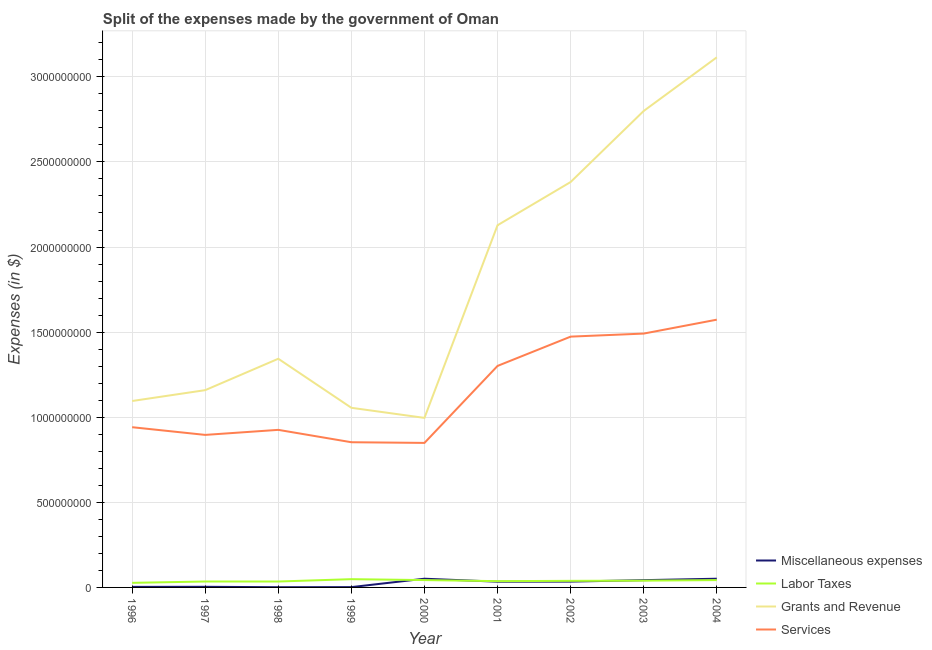Is the number of lines equal to the number of legend labels?
Make the answer very short. Yes. What is the amount spent on services in 2002?
Ensure brevity in your answer.  1.47e+09. Across all years, what is the maximum amount spent on services?
Your response must be concise. 1.57e+09. Across all years, what is the minimum amount spent on grants and revenue?
Your answer should be compact. 9.96e+08. What is the total amount spent on labor taxes in the graph?
Offer a very short reply. 3.46e+08. What is the difference between the amount spent on labor taxes in 2001 and that in 2003?
Keep it short and to the point. -3.00e+06. What is the difference between the amount spent on labor taxes in 2002 and the amount spent on grants and revenue in 2000?
Give a very brief answer. -9.58e+08. What is the average amount spent on services per year?
Provide a succinct answer. 1.15e+09. In the year 2000, what is the difference between the amount spent on services and amount spent on miscellaneous expenses?
Provide a succinct answer. 7.98e+08. What is the ratio of the amount spent on services in 1999 to that in 2000?
Ensure brevity in your answer.  1. Is the difference between the amount spent on miscellaneous expenses in 1998 and 2004 greater than the difference between the amount spent on grants and revenue in 1998 and 2004?
Keep it short and to the point. Yes. What is the difference between the highest and the second highest amount spent on grants and revenue?
Ensure brevity in your answer.  3.15e+08. What is the difference between the highest and the lowest amount spent on services?
Provide a short and direct response. 7.24e+08. In how many years, is the amount spent on labor taxes greater than the average amount spent on labor taxes taken over all years?
Ensure brevity in your answer.  5. Is the sum of the amount spent on services in 1996 and 2004 greater than the maximum amount spent on miscellaneous expenses across all years?
Your response must be concise. Yes. Is it the case that in every year, the sum of the amount spent on services and amount spent on miscellaneous expenses is greater than the sum of amount spent on labor taxes and amount spent on grants and revenue?
Your answer should be compact. No. Does the amount spent on labor taxes monotonically increase over the years?
Make the answer very short. No. Is the amount spent on miscellaneous expenses strictly greater than the amount spent on grants and revenue over the years?
Offer a terse response. No. Is the amount spent on services strictly less than the amount spent on miscellaneous expenses over the years?
Your response must be concise. No. What is the difference between two consecutive major ticks on the Y-axis?
Provide a short and direct response. 5.00e+08. Are the values on the major ticks of Y-axis written in scientific E-notation?
Give a very brief answer. No. Does the graph contain grids?
Offer a terse response. Yes. How many legend labels are there?
Your answer should be very brief. 4. How are the legend labels stacked?
Provide a succinct answer. Vertical. What is the title of the graph?
Give a very brief answer. Split of the expenses made by the government of Oman. What is the label or title of the X-axis?
Keep it short and to the point. Year. What is the label or title of the Y-axis?
Ensure brevity in your answer.  Expenses (in $). What is the Expenses (in $) in Miscellaneous expenses in 1996?
Make the answer very short. 3.20e+06. What is the Expenses (in $) in Labor Taxes in 1996?
Give a very brief answer. 2.69e+07. What is the Expenses (in $) of Grants and Revenue in 1996?
Offer a very short reply. 1.10e+09. What is the Expenses (in $) in Services in 1996?
Ensure brevity in your answer.  9.41e+08. What is the Expenses (in $) in Miscellaneous expenses in 1997?
Give a very brief answer. 3.70e+06. What is the Expenses (in $) of Labor Taxes in 1997?
Ensure brevity in your answer.  3.48e+07. What is the Expenses (in $) in Grants and Revenue in 1997?
Your answer should be very brief. 1.16e+09. What is the Expenses (in $) of Services in 1997?
Offer a terse response. 8.96e+08. What is the Expenses (in $) in Miscellaneous expenses in 1998?
Your answer should be very brief. 1.30e+06. What is the Expenses (in $) of Labor Taxes in 1998?
Provide a succinct answer. 3.47e+07. What is the Expenses (in $) in Grants and Revenue in 1998?
Make the answer very short. 1.34e+09. What is the Expenses (in $) of Services in 1998?
Your answer should be compact. 9.26e+08. What is the Expenses (in $) of Miscellaneous expenses in 1999?
Provide a succinct answer. 1.80e+06. What is the Expenses (in $) of Labor Taxes in 1999?
Offer a very short reply. 4.85e+07. What is the Expenses (in $) of Grants and Revenue in 1999?
Your answer should be compact. 1.06e+09. What is the Expenses (in $) of Services in 1999?
Your answer should be very brief. 8.53e+08. What is the Expenses (in $) of Miscellaneous expenses in 2000?
Your answer should be compact. 5.12e+07. What is the Expenses (in $) in Labor Taxes in 2000?
Keep it short and to the point. 4.32e+07. What is the Expenses (in $) of Grants and Revenue in 2000?
Make the answer very short. 9.96e+08. What is the Expenses (in $) of Services in 2000?
Make the answer very short. 8.49e+08. What is the Expenses (in $) of Miscellaneous expenses in 2001?
Give a very brief answer. 3.37e+07. What is the Expenses (in $) of Labor Taxes in 2001?
Provide a short and direct response. 3.68e+07. What is the Expenses (in $) of Grants and Revenue in 2001?
Ensure brevity in your answer.  2.13e+09. What is the Expenses (in $) in Services in 2001?
Provide a succinct answer. 1.30e+09. What is the Expenses (in $) of Miscellaneous expenses in 2002?
Keep it short and to the point. 3.43e+07. What is the Expenses (in $) of Labor Taxes in 2002?
Your answer should be compact. 3.87e+07. What is the Expenses (in $) of Grants and Revenue in 2002?
Your response must be concise. 2.38e+09. What is the Expenses (in $) of Services in 2002?
Keep it short and to the point. 1.47e+09. What is the Expenses (in $) of Miscellaneous expenses in 2003?
Your response must be concise. 4.27e+07. What is the Expenses (in $) of Labor Taxes in 2003?
Provide a short and direct response. 3.98e+07. What is the Expenses (in $) in Grants and Revenue in 2003?
Your answer should be compact. 2.80e+09. What is the Expenses (in $) of Services in 2003?
Make the answer very short. 1.49e+09. What is the Expenses (in $) of Miscellaneous expenses in 2004?
Offer a terse response. 5.12e+07. What is the Expenses (in $) in Labor Taxes in 2004?
Your answer should be very brief. 4.31e+07. What is the Expenses (in $) of Grants and Revenue in 2004?
Keep it short and to the point. 3.11e+09. What is the Expenses (in $) of Services in 2004?
Offer a very short reply. 1.57e+09. Across all years, what is the maximum Expenses (in $) of Miscellaneous expenses?
Offer a very short reply. 5.12e+07. Across all years, what is the maximum Expenses (in $) in Labor Taxes?
Offer a very short reply. 4.85e+07. Across all years, what is the maximum Expenses (in $) of Grants and Revenue?
Keep it short and to the point. 3.11e+09. Across all years, what is the maximum Expenses (in $) in Services?
Make the answer very short. 1.57e+09. Across all years, what is the minimum Expenses (in $) in Miscellaneous expenses?
Offer a very short reply. 1.30e+06. Across all years, what is the minimum Expenses (in $) in Labor Taxes?
Give a very brief answer. 2.69e+07. Across all years, what is the minimum Expenses (in $) of Grants and Revenue?
Your answer should be compact. 9.96e+08. Across all years, what is the minimum Expenses (in $) in Services?
Give a very brief answer. 8.49e+08. What is the total Expenses (in $) in Miscellaneous expenses in the graph?
Offer a very short reply. 2.23e+08. What is the total Expenses (in $) in Labor Taxes in the graph?
Make the answer very short. 3.46e+08. What is the total Expenses (in $) in Grants and Revenue in the graph?
Keep it short and to the point. 1.61e+1. What is the total Expenses (in $) of Services in the graph?
Offer a very short reply. 1.03e+1. What is the difference between the Expenses (in $) of Miscellaneous expenses in 1996 and that in 1997?
Make the answer very short. -5.00e+05. What is the difference between the Expenses (in $) in Labor Taxes in 1996 and that in 1997?
Make the answer very short. -7.90e+06. What is the difference between the Expenses (in $) of Grants and Revenue in 1996 and that in 1997?
Make the answer very short. -6.38e+07. What is the difference between the Expenses (in $) of Services in 1996 and that in 1997?
Give a very brief answer. 4.52e+07. What is the difference between the Expenses (in $) in Miscellaneous expenses in 1996 and that in 1998?
Your answer should be compact. 1.90e+06. What is the difference between the Expenses (in $) of Labor Taxes in 1996 and that in 1998?
Make the answer very short. -7.80e+06. What is the difference between the Expenses (in $) of Grants and Revenue in 1996 and that in 1998?
Give a very brief answer. -2.48e+08. What is the difference between the Expenses (in $) of Services in 1996 and that in 1998?
Your response must be concise. 1.56e+07. What is the difference between the Expenses (in $) in Miscellaneous expenses in 1996 and that in 1999?
Give a very brief answer. 1.40e+06. What is the difference between the Expenses (in $) of Labor Taxes in 1996 and that in 1999?
Provide a succinct answer. -2.16e+07. What is the difference between the Expenses (in $) of Grants and Revenue in 1996 and that in 1999?
Provide a short and direct response. 3.99e+07. What is the difference between the Expenses (in $) of Services in 1996 and that in 1999?
Make the answer very short. 8.83e+07. What is the difference between the Expenses (in $) of Miscellaneous expenses in 1996 and that in 2000?
Keep it short and to the point. -4.80e+07. What is the difference between the Expenses (in $) of Labor Taxes in 1996 and that in 2000?
Give a very brief answer. -1.63e+07. What is the difference between the Expenses (in $) of Grants and Revenue in 1996 and that in 2000?
Provide a short and direct response. 9.91e+07. What is the difference between the Expenses (in $) in Services in 1996 and that in 2000?
Ensure brevity in your answer.  9.23e+07. What is the difference between the Expenses (in $) of Miscellaneous expenses in 1996 and that in 2001?
Offer a very short reply. -3.05e+07. What is the difference between the Expenses (in $) of Labor Taxes in 1996 and that in 2001?
Your response must be concise. -9.90e+06. What is the difference between the Expenses (in $) in Grants and Revenue in 1996 and that in 2001?
Your response must be concise. -1.03e+09. What is the difference between the Expenses (in $) of Services in 1996 and that in 2001?
Provide a succinct answer. -3.60e+08. What is the difference between the Expenses (in $) in Miscellaneous expenses in 1996 and that in 2002?
Offer a very short reply. -3.11e+07. What is the difference between the Expenses (in $) of Labor Taxes in 1996 and that in 2002?
Your answer should be compact. -1.18e+07. What is the difference between the Expenses (in $) of Grants and Revenue in 1996 and that in 2002?
Your response must be concise. -1.29e+09. What is the difference between the Expenses (in $) of Services in 1996 and that in 2002?
Your response must be concise. -5.32e+08. What is the difference between the Expenses (in $) of Miscellaneous expenses in 1996 and that in 2003?
Your answer should be compact. -3.95e+07. What is the difference between the Expenses (in $) in Labor Taxes in 1996 and that in 2003?
Make the answer very short. -1.29e+07. What is the difference between the Expenses (in $) in Grants and Revenue in 1996 and that in 2003?
Provide a short and direct response. -1.70e+09. What is the difference between the Expenses (in $) of Services in 1996 and that in 2003?
Provide a succinct answer. -5.50e+08. What is the difference between the Expenses (in $) in Miscellaneous expenses in 1996 and that in 2004?
Your answer should be very brief. -4.80e+07. What is the difference between the Expenses (in $) in Labor Taxes in 1996 and that in 2004?
Keep it short and to the point. -1.62e+07. What is the difference between the Expenses (in $) of Grants and Revenue in 1996 and that in 2004?
Your answer should be very brief. -2.02e+09. What is the difference between the Expenses (in $) of Services in 1996 and that in 2004?
Provide a short and direct response. -6.32e+08. What is the difference between the Expenses (in $) of Miscellaneous expenses in 1997 and that in 1998?
Ensure brevity in your answer.  2.40e+06. What is the difference between the Expenses (in $) in Labor Taxes in 1997 and that in 1998?
Your answer should be very brief. 1.00e+05. What is the difference between the Expenses (in $) of Grants and Revenue in 1997 and that in 1998?
Offer a terse response. -1.84e+08. What is the difference between the Expenses (in $) of Services in 1997 and that in 1998?
Your response must be concise. -2.96e+07. What is the difference between the Expenses (in $) of Miscellaneous expenses in 1997 and that in 1999?
Your answer should be compact. 1.90e+06. What is the difference between the Expenses (in $) in Labor Taxes in 1997 and that in 1999?
Make the answer very short. -1.37e+07. What is the difference between the Expenses (in $) of Grants and Revenue in 1997 and that in 1999?
Ensure brevity in your answer.  1.04e+08. What is the difference between the Expenses (in $) of Services in 1997 and that in 1999?
Your answer should be very brief. 4.31e+07. What is the difference between the Expenses (in $) of Miscellaneous expenses in 1997 and that in 2000?
Keep it short and to the point. -4.75e+07. What is the difference between the Expenses (in $) in Labor Taxes in 1997 and that in 2000?
Ensure brevity in your answer.  -8.40e+06. What is the difference between the Expenses (in $) of Grants and Revenue in 1997 and that in 2000?
Ensure brevity in your answer.  1.63e+08. What is the difference between the Expenses (in $) in Services in 1997 and that in 2000?
Provide a short and direct response. 4.71e+07. What is the difference between the Expenses (in $) in Miscellaneous expenses in 1997 and that in 2001?
Your answer should be compact. -3.00e+07. What is the difference between the Expenses (in $) in Labor Taxes in 1997 and that in 2001?
Ensure brevity in your answer.  -2.00e+06. What is the difference between the Expenses (in $) in Grants and Revenue in 1997 and that in 2001?
Make the answer very short. -9.69e+08. What is the difference between the Expenses (in $) in Services in 1997 and that in 2001?
Your answer should be compact. -4.05e+08. What is the difference between the Expenses (in $) in Miscellaneous expenses in 1997 and that in 2002?
Your response must be concise. -3.06e+07. What is the difference between the Expenses (in $) of Labor Taxes in 1997 and that in 2002?
Your response must be concise. -3.90e+06. What is the difference between the Expenses (in $) of Grants and Revenue in 1997 and that in 2002?
Provide a succinct answer. -1.22e+09. What is the difference between the Expenses (in $) in Services in 1997 and that in 2002?
Your response must be concise. -5.77e+08. What is the difference between the Expenses (in $) of Miscellaneous expenses in 1997 and that in 2003?
Give a very brief answer. -3.90e+07. What is the difference between the Expenses (in $) in Labor Taxes in 1997 and that in 2003?
Ensure brevity in your answer.  -5.00e+06. What is the difference between the Expenses (in $) of Grants and Revenue in 1997 and that in 2003?
Keep it short and to the point. -1.64e+09. What is the difference between the Expenses (in $) of Services in 1997 and that in 2003?
Your answer should be compact. -5.95e+08. What is the difference between the Expenses (in $) of Miscellaneous expenses in 1997 and that in 2004?
Provide a short and direct response. -4.75e+07. What is the difference between the Expenses (in $) of Labor Taxes in 1997 and that in 2004?
Give a very brief answer. -8.30e+06. What is the difference between the Expenses (in $) in Grants and Revenue in 1997 and that in 2004?
Give a very brief answer. -1.96e+09. What is the difference between the Expenses (in $) in Services in 1997 and that in 2004?
Offer a terse response. -6.77e+08. What is the difference between the Expenses (in $) of Miscellaneous expenses in 1998 and that in 1999?
Give a very brief answer. -5.00e+05. What is the difference between the Expenses (in $) in Labor Taxes in 1998 and that in 1999?
Offer a very short reply. -1.38e+07. What is the difference between the Expenses (in $) of Grants and Revenue in 1998 and that in 1999?
Provide a short and direct response. 2.88e+08. What is the difference between the Expenses (in $) in Services in 1998 and that in 1999?
Keep it short and to the point. 7.27e+07. What is the difference between the Expenses (in $) of Miscellaneous expenses in 1998 and that in 2000?
Give a very brief answer. -4.99e+07. What is the difference between the Expenses (in $) of Labor Taxes in 1998 and that in 2000?
Provide a succinct answer. -8.50e+06. What is the difference between the Expenses (in $) of Grants and Revenue in 1998 and that in 2000?
Your answer should be very brief. 3.47e+08. What is the difference between the Expenses (in $) in Services in 1998 and that in 2000?
Give a very brief answer. 7.67e+07. What is the difference between the Expenses (in $) of Miscellaneous expenses in 1998 and that in 2001?
Provide a succinct answer. -3.24e+07. What is the difference between the Expenses (in $) in Labor Taxes in 1998 and that in 2001?
Your answer should be very brief. -2.10e+06. What is the difference between the Expenses (in $) in Grants and Revenue in 1998 and that in 2001?
Your response must be concise. -7.84e+08. What is the difference between the Expenses (in $) of Services in 1998 and that in 2001?
Provide a succinct answer. -3.76e+08. What is the difference between the Expenses (in $) in Miscellaneous expenses in 1998 and that in 2002?
Offer a terse response. -3.30e+07. What is the difference between the Expenses (in $) of Labor Taxes in 1998 and that in 2002?
Your answer should be compact. -4.00e+06. What is the difference between the Expenses (in $) in Grants and Revenue in 1998 and that in 2002?
Ensure brevity in your answer.  -1.04e+09. What is the difference between the Expenses (in $) of Services in 1998 and that in 2002?
Your answer should be compact. -5.48e+08. What is the difference between the Expenses (in $) in Miscellaneous expenses in 1998 and that in 2003?
Your answer should be compact. -4.14e+07. What is the difference between the Expenses (in $) of Labor Taxes in 1998 and that in 2003?
Your answer should be compact. -5.10e+06. What is the difference between the Expenses (in $) in Grants and Revenue in 1998 and that in 2003?
Provide a succinct answer. -1.46e+09. What is the difference between the Expenses (in $) in Services in 1998 and that in 2003?
Provide a short and direct response. -5.66e+08. What is the difference between the Expenses (in $) of Miscellaneous expenses in 1998 and that in 2004?
Provide a succinct answer. -4.99e+07. What is the difference between the Expenses (in $) of Labor Taxes in 1998 and that in 2004?
Provide a succinct answer. -8.40e+06. What is the difference between the Expenses (in $) in Grants and Revenue in 1998 and that in 2004?
Offer a terse response. -1.77e+09. What is the difference between the Expenses (in $) of Services in 1998 and that in 2004?
Make the answer very short. -6.47e+08. What is the difference between the Expenses (in $) in Miscellaneous expenses in 1999 and that in 2000?
Your answer should be very brief. -4.94e+07. What is the difference between the Expenses (in $) of Labor Taxes in 1999 and that in 2000?
Your answer should be very brief. 5.30e+06. What is the difference between the Expenses (in $) in Grants and Revenue in 1999 and that in 2000?
Give a very brief answer. 5.92e+07. What is the difference between the Expenses (in $) in Miscellaneous expenses in 1999 and that in 2001?
Give a very brief answer. -3.19e+07. What is the difference between the Expenses (in $) in Labor Taxes in 1999 and that in 2001?
Give a very brief answer. 1.17e+07. What is the difference between the Expenses (in $) of Grants and Revenue in 1999 and that in 2001?
Your answer should be compact. -1.07e+09. What is the difference between the Expenses (in $) in Services in 1999 and that in 2001?
Provide a short and direct response. -4.48e+08. What is the difference between the Expenses (in $) in Miscellaneous expenses in 1999 and that in 2002?
Offer a terse response. -3.25e+07. What is the difference between the Expenses (in $) in Labor Taxes in 1999 and that in 2002?
Make the answer very short. 9.80e+06. What is the difference between the Expenses (in $) of Grants and Revenue in 1999 and that in 2002?
Keep it short and to the point. -1.33e+09. What is the difference between the Expenses (in $) of Services in 1999 and that in 2002?
Your answer should be compact. -6.20e+08. What is the difference between the Expenses (in $) of Miscellaneous expenses in 1999 and that in 2003?
Provide a succinct answer. -4.09e+07. What is the difference between the Expenses (in $) of Labor Taxes in 1999 and that in 2003?
Ensure brevity in your answer.  8.70e+06. What is the difference between the Expenses (in $) in Grants and Revenue in 1999 and that in 2003?
Offer a terse response. -1.74e+09. What is the difference between the Expenses (in $) in Services in 1999 and that in 2003?
Provide a succinct answer. -6.38e+08. What is the difference between the Expenses (in $) in Miscellaneous expenses in 1999 and that in 2004?
Your answer should be very brief. -4.94e+07. What is the difference between the Expenses (in $) of Labor Taxes in 1999 and that in 2004?
Provide a succinct answer. 5.40e+06. What is the difference between the Expenses (in $) of Grants and Revenue in 1999 and that in 2004?
Provide a short and direct response. -2.06e+09. What is the difference between the Expenses (in $) in Services in 1999 and that in 2004?
Ensure brevity in your answer.  -7.20e+08. What is the difference between the Expenses (in $) of Miscellaneous expenses in 2000 and that in 2001?
Provide a short and direct response. 1.75e+07. What is the difference between the Expenses (in $) of Labor Taxes in 2000 and that in 2001?
Ensure brevity in your answer.  6.40e+06. What is the difference between the Expenses (in $) in Grants and Revenue in 2000 and that in 2001?
Offer a very short reply. -1.13e+09. What is the difference between the Expenses (in $) in Services in 2000 and that in 2001?
Your answer should be compact. -4.52e+08. What is the difference between the Expenses (in $) of Miscellaneous expenses in 2000 and that in 2002?
Provide a short and direct response. 1.69e+07. What is the difference between the Expenses (in $) in Labor Taxes in 2000 and that in 2002?
Provide a succinct answer. 4.50e+06. What is the difference between the Expenses (in $) of Grants and Revenue in 2000 and that in 2002?
Offer a terse response. -1.39e+09. What is the difference between the Expenses (in $) of Services in 2000 and that in 2002?
Provide a short and direct response. -6.24e+08. What is the difference between the Expenses (in $) of Miscellaneous expenses in 2000 and that in 2003?
Your answer should be compact. 8.50e+06. What is the difference between the Expenses (in $) in Labor Taxes in 2000 and that in 2003?
Keep it short and to the point. 3.40e+06. What is the difference between the Expenses (in $) in Grants and Revenue in 2000 and that in 2003?
Give a very brief answer. -1.80e+09. What is the difference between the Expenses (in $) in Services in 2000 and that in 2003?
Give a very brief answer. -6.42e+08. What is the difference between the Expenses (in $) in Miscellaneous expenses in 2000 and that in 2004?
Provide a succinct answer. 0. What is the difference between the Expenses (in $) of Labor Taxes in 2000 and that in 2004?
Ensure brevity in your answer.  1.00e+05. What is the difference between the Expenses (in $) in Grants and Revenue in 2000 and that in 2004?
Offer a terse response. -2.12e+09. What is the difference between the Expenses (in $) in Services in 2000 and that in 2004?
Offer a very short reply. -7.24e+08. What is the difference between the Expenses (in $) in Miscellaneous expenses in 2001 and that in 2002?
Give a very brief answer. -6.00e+05. What is the difference between the Expenses (in $) of Labor Taxes in 2001 and that in 2002?
Your response must be concise. -1.90e+06. What is the difference between the Expenses (in $) of Grants and Revenue in 2001 and that in 2002?
Your response must be concise. -2.54e+08. What is the difference between the Expenses (in $) in Services in 2001 and that in 2002?
Offer a terse response. -1.72e+08. What is the difference between the Expenses (in $) in Miscellaneous expenses in 2001 and that in 2003?
Make the answer very short. -9.00e+06. What is the difference between the Expenses (in $) of Grants and Revenue in 2001 and that in 2003?
Your response must be concise. -6.72e+08. What is the difference between the Expenses (in $) of Services in 2001 and that in 2003?
Provide a short and direct response. -1.90e+08. What is the difference between the Expenses (in $) of Miscellaneous expenses in 2001 and that in 2004?
Provide a succinct answer. -1.75e+07. What is the difference between the Expenses (in $) in Labor Taxes in 2001 and that in 2004?
Your answer should be compact. -6.30e+06. What is the difference between the Expenses (in $) in Grants and Revenue in 2001 and that in 2004?
Give a very brief answer. -9.87e+08. What is the difference between the Expenses (in $) of Services in 2001 and that in 2004?
Your answer should be very brief. -2.72e+08. What is the difference between the Expenses (in $) in Miscellaneous expenses in 2002 and that in 2003?
Keep it short and to the point. -8.40e+06. What is the difference between the Expenses (in $) in Labor Taxes in 2002 and that in 2003?
Provide a succinct answer. -1.10e+06. What is the difference between the Expenses (in $) of Grants and Revenue in 2002 and that in 2003?
Offer a very short reply. -4.18e+08. What is the difference between the Expenses (in $) in Services in 2002 and that in 2003?
Provide a succinct answer. -1.79e+07. What is the difference between the Expenses (in $) in Miscellaneous expenses in 2002 and that in 2004?
Your response must be concise. -1.69e+07. What is the difference between the Expenses (in $) in Labor Taxes in 2002 and that in 2004?
Make the answer very short. -4.40e+06. What is the difference between the Expenses (in $) of Grants and Revenue in 2002 and that in 2004?
Provide a short and direct response. -7.33e+08. What is the difference between the Expenses (in $) in Services in 2002 and that in 2004?
Provide a short and direct response. -9.96e+07. What is the difference between the Expenses (in $) of Miscellaneous expenses in 2003 and that in 2004?
Your response must be concise. -8.50e+06. What is the difference between the Expenses (in $) in Labor Taxes in 2003 and that in 2004?
Offer a terse response. -3.30e+06. What is the difference between the Expenses (in $) in Grants and Revenue in 2003 and that in 2004?
Your answer should be compact. -3.15e+08. What is the difference between the Expenses (in $) of Services in 2003 and that in 2004?
Ensure brevity in your answer.  -8.17e+07. What is the difference between the Expenses (in $) of Miscellaneous expenses in 1996 and the Expenses (in $) of Labor Taxes in 1997?
Make the answer very short. -3.16e+07. What is the difference between the Expenses (in $) in Miscellaneous expenses in 1996 and the Expenses (in $) in Grants and Revenue in 1997?
Give a very brief answer. -1.16e+09. What is the difference between the Expenses (in $) in Miscellaneous expenses in 1996 and the Expenses (in $) in Services in 1997?
Your answer should be very brief. -8.93e+08. What is the difference between the Expenses (in $) of Labor Taxes in 1996 and the Expenses (in $) of Grants and Revenue in 1997?
Your response must be concise. -1.13e+09. What is the difference between the Expenses (in $) of Labor Taxes in 1996 and the Expenses (in $) of Services in 1997?
Ensure brevity in your answer.  -8.69e+08. What is the difference between the Expenses (in $) in Grants and Revenue in 1996 and the Expenses (in $) in Services in 1997?
Keep it short and to the point. 1.99e+08. What is the difference between the Expenses (in $) of Miscellaneous expenses in 1996 and the Expenses (in $) of Labor Taxes in 1998?
Ensure brevity in your answer.  -3.15e+07. What is the difference between the Expenses (in $) of Miscellaneous expenses in 1996 and the Expenses (in $) of Grants and Revenue in 1998?
Provide a short and direct response. -1.34e+09. What is the difference between the Expenses (in $) of Miscellaneous expenses in 1996 and the Expenses (in $) of Services in 1998?
Your response must be concise. -9.23e+08. What is the difference between the Expenses (in $) of Labor Taxes in 1996 and the Expenses (in $) of Grants and Revenue in 1998?
Provide a short and direct response. -1.32e+09. What is the difference between the Expenses (in $) of Labor Taxes in 1996 and the Expenses (in $) of Services in 1998?
Provide a succinct answer. -8.99e+08. What is the difference between the Expenses (in $) in Grants and Revenue in 1996 and the Expenses (in $) in Services in 1998?
Provide a succinct answer. 1.70e+08. What is the difference between the Expenses (in $) in Miscellaneous expenses in 1996 and the Expenses (in $) in Labor Taxes in 1999?
Offer a very short reply. -4.53e+07. What is the difference between the Expenses (in $) of Miscellaneous expenses in 1996 and the Expenses (in $) of Grants and Revenue in 1999?
Offer a terse response. -1.05e+09. What is the difference between the Expenses (in $) of Miscellaneous expenses in 1996 and the Expenses (in $) of Services in 1999?
Keep it short and to the point. -8.50e+08. What is the difference between the Expenses (in $) of Labor Taxes in 1996 and the Expenses (in $) of Grants and Revenue in 1999?
Your answer should be very brief. -1.03e+09. What is the difference between the Expenses (in $) of Labor Taxes in 1996 and the Expenses (in $) of Services in 1999?
Your answer should be compact. -8.26e+08. What is the difference between the Expenses (in $) of Grants and Revenue in 1996 and the Expenses (in $) of Services in 1999?
Offer a terse response. 2.42e+08. What is the difference between the Expenses (in $) of Miscellaneous expenses in 1996 and the Expenses (in $) of Labor Taxes in 2000?
Ensure brevity in your answer.  -4.00e+07. What is the difference between the Expenses (in $) of Miscellaneous expenses in 1996 and the Expenses (in $) of Grants and Revenue in 2000?
Offer a terse response. -9.93e+08. What is the difference between the Expenses (in $) of Miscellaneous expenses in 1996 and the Expenses (in $) of Services in 2000?
Ensure brevity in your answer.  -8.46e+08. What is the difference between the Expenses (in $) in Labor Taxes in 1996 and the Expenses (in $) in Grants and Revenue in 2000?
Make the answer very short. -9.69e+08. What is the difference between the Expenses (in $) in Labor Taxes in 1996 and the Expenses (in $) in Services in 2000?
Offer a very short reply. -8.22e+08. What is the difference between the Expenses (in $) in Grants and Revenue in 1996 and the Expenses (in $) in Services in 2000?
Provide a succinct answer. 2.46e+08. What is the difference between the Expenses (in $) of Miscellaneous expenses in 1996 and the Expenses (in $) of Labor Taxes in 2001?
Your answer should be very brief. -3.36e+07. What is the difference between the Expenses (in $) in Miscellaneous expenses in 1996 and the Expenses (in $) in Grants and Revenue in 2001?
Provide a succinct answer. -2.12e+09. What is the difference between the Expenses (in $) in Miscellaneous expenses in 1996 and the Expenses (in $) in Services in 2001?
Provide a succinct answer. -1.30e+09. What is the difference between the Expenses (in $) in Labor Taxes in 1996 and the Expenses (in $) in Grants and Revenue in 2001?
Ensure brevity in your answer.  -2.10e+09. What is the difference between the Expenses (in $) of Labor Taxes in 1996 and the Expenses (in $) of Services in 2001?
Your answer should be compact. -1.27e+09. What is the difference between the Expenses (in $) of Grants and Revenue in 1996 and the Expenses (in $) of Services in 2001?
Offer a terse response. -2.06e+08. What is the difference between the Expenses (in $) in Miscellaneous expenses in 1996 and the Expenses (in $) in Labor Taxes in 2002?
Your answer should be compact. -3.55e+07. What is the difference between the Expenses (in $) in Miscellaneous expenses in 1996 and the Expenses (in $) in Grants and Revenue in 2002?
Provide a short and direct response. -2.38e+09. What is the difference between the Expenses (in $) in Miscellaneous expenses in 1996 and the Expenses (in $) in Services in 2002?
Provide a succinct answer. -1.47e+09. What is the difference between the Expenses (in $) of Labor Taxes in 1996 and the Expenses (in $) of Grants and Revenue in 2002?
Offer a terse response. -2.36e+09. What is the difference between the Expenses (in $) in Labor Taxes in 1996 and the Expenses (in $) in Services in 2002?
Keep it short and to the point. -1.45e+09. What is the difference between the Expenses (in $) in Grants and Revenue in 1996 and the Expenses (in $) in Services in 2002?
Your answer should be very brief. -3.78e+08. What is the difference between the Expenses (in $) of Miscellaneous expenses in 1996 and the Expenses (in $) of Labor Taxes in 2003?
Keep it short and to the point. -3.66e+07. What is the difference between the Expenses (in $) of Miscellaneous expenses in 1996 and the Expenses (in $) of Grants and Revenue in 2003?
Your response must be concise. -2.80e+09. What is the difference between the Expenses (in $) in Miscellaneous expenses in 1996 and the Expenses (in $) in Services in 2003?
Offer a terse response. -1.49e+09. What is the difference between the Expenses (in $) in Labor Taxes in 1996 and the Expenses (in $) in Grants and Revenue in 2003?
Offer a terse response. -2.77e+09. What is the difference between the Expenses (in $) of Labor Taxes in 1996 and the Expenses (in $) of Services in 2003?
Your answer should be very brief. -1.46e+09. What is the difference between the Expenses (in $) of Grants and Revenue in 1996 and the Expenses (in $) of Services in 2003?
Your answer should be compact. -3.96e+08. What is the difference between the Expenses (in $) in Miscellaneous expenses in 1996 and the Expenses (in $) in Labor Taxes in 2004?
Your response must be concise. -3.99e+07. What is the difference between the Expenses (in $) of Miscellaneous expenses in 1996 and the Expenses (in $) of Grants and Revenue in 2004?
Ensure brevity in your answer.  -3.11e+09. What is the difference between the Expenses (in $) of Miscellaneous expenses in 1996 and the Expenses (in $) of Services in 2004?
Offer a terse response. -1.57e+09. What is the difference between the Expenses (in $) of Labor Taxes in 1996 and the Expenses (in $) of Grants and Revenue in 2004?
Offer a terse response. -3.09e+09. What is the difference between the Expenses (in $) in Labor Taxes in 1996 and the Expenses (in $) in Services in 2004?
Provide a succinct answer. -1.55e+09. What is the difference between the Expenses (in $) in Grants and Revenue in 1996 and the Expenses (in $) in Services in 2004?
Make the answer very short. -4.78e+08. What is the difference between the Expenses (in $) of Miscellaneous expenses in 1997 and the Expenses (in $) of Labor Taxes in 1998?
Keep it short and to the point. -3.10e+07. What is the difference between the Expenses (in $) of Miscellaneous expenses in 1997 and the Expenses (in $) of Grants and Revenue in 1998?
Your answer should be very brief. -1.34e+09. What is the difference between the Expenses (in $) in Miscellaneous expenses in 1997 and the Expenses (in $) in Services in 1998?
Provide a short and direct response. -9.22e+08. What is the difference between the Expenses (in $) of Labor Taxes in 1997 and the Expenses (in $) of Grants and Revenue in 1998?
Offer a terse response. -1.31e+09. What is the difference between the Expenses (in $) in Labor Taxes in 1997 and the Expenses (in $) in Services in 1998?
Offer a very short reply. -8.91e+08. What is the difference between the Expenses (in $) in Grants and Revenue in 1997 and the Expenses (in $) in Services in 1998?
Provide a succinct answer. 2.33e+08. What is the difference between the Expenses (in $) of Miscellaneous expenses in 1997 and the Expenses (in $) of Labor Taxes in 1999?
Offer a terse response. -4.48e+07. What is the difference between the Expenses (in $) in Miscellaneous expenses in 1997 and the Expenses (in $) in Grants and Revenue in 1999?
Provide a short and direct response. -1.05e+09. What is the difference between the Expenses (in $) of Miscellaneous expenses in 1997 and the Expenses (in $) of Services in 1999?
Give a very brief answer. -8.49e+08. What is the difference between the Expenses (in $) of Labor Taxes in 1997 and the Expenses (in $) of Grants and Revenue in 1999?
Provide a succinct answer. -1.02e+09. What is the difference between the Expenses (in $) of Labor Taxes in 1997 and the Expenses (in $) of Services in 1999?
Ensure brevity in your answer.  -8.18e+08. What is the difference between the Expenses (in $) in Grants and Revenue in 1997 and the Expenses (in $) in Services in 1999?
Your answer should be very brief. 3.06e+08. What is the difference between the Expenses (in $) in Miscellaneous expenses in 1997 and the Expenses (in $) in Labor Taxes in 2000?
Your response must be concise. -3.95e+07. What is the difference between the Expenses (in $) of Miscellaneous expenses in 1997 and the Expenses (in $) of Grants and Revenue in 2000?
Keep it short and to the point. -9.92e+08. What is the difference between the Expenses (in $) of Miscellaneous expenses in 1997 and the Expenses (in $) of Services in 2000?
Your answer should be compact. -8.45e+08. What is the difference between the Expenses (in $) of Labor Taxes in 1997 and the Expenses (in $) of Grants and Revenue in 2000?
Ensure brevity in your answer.  -9.61e+08. What is the difference between the Expenses (in $) in Labor Taxes in 1997 and the Expenses (in $) in Services in 2000?
Your answer should be very brief. -8.14e+08. What is the difference between the Expenses (in $) in Grants and Revenue in 1997 and the Expenses (in $) in Services in 2000?
Offer a very short reply. 3.10e+08. What is the difference between the Expenses (in $) in Miscellaneous expenses in 1997 and the Expenses (in $) in Labor Taxes in 2001?
Offer a terse response. -3.31e+07. What is the difference between the Expenses (in $) in Miscellaneous expenses in 1997 and the Expenses (in $) in Grants and Revenue in 2001?
Give a very brief answer. -2.12e+09. What is the difference between the Expenses (in $) of Miscellaneous expenses in 1997 and the Expenses (in $) of Services in 2001?
Offer a very short reply. -1.30e+09. What is the difference between the Expenses (in $) of Labor Taxes in 1997 and the Expenses (in $) of Grants and Revenue in 2001?
Make the answer very short. -2.09e+09. What is the difference between the Expenses (in $) of Labor Taxes in 1997 and the Expenses (in $) of Services in 2001?
Offer a terse response. -1.27e+09. What is the difference between the Expenses (in $) of Grants and Revenue in 1997 and the Expenses (in $) of Services in 2001?
Provide a succinct answer. -1.42e+08. What is the difference between the Expenses (in $) of Miscellaneous expenses in 1997 and the Expenses (in $) of Labor Taxes in 2002?
Your answer should be very brief. -3.50e+07. What is the difference between the Expenses (in $) of Miscellaneous expenses in 1997 and the Expenses (in $) of Grants and Revenue in 2002?
Offer a very short reply. -2.38e+09. What is the difference between the Expenses (in $) in Miscellaneous expenses in 1997 and the Expenses (in $) in Services in 2002?
Give a very brief answer. -1.47e+09. What is the difference between the Expenses (in $) in Labor Taxes in 1997 and the Expenses (in $) in Grants and Revenue in 2002?
Give a very brief answer. -2.35e+09. What is the difference between the Expenses (in $) in Labor Taxes in 1997 and the Expenses (in $) in Services in 2002?
Make the answer very short. -1.44e+09. What is the difference between the Expenses (in $) of Grants and Revenue in 1997 and the Expenses (in $) of Services in 2002?
Provide a short and direct response. -3.14e+08. What is the difference between the Expenses (in $) of Miscellaneous expenses in 1997 and the Expenses (in $) of Labor Taxes in 2003?
Offer a very short reply. -3.61e+07. What is the difference between the Expenses (in $) in Miscellaneous expenses in 1997 and the Expenses (in $) in Grants and Revenue in 2003?
Ensure brevity in your answer.  -2.80e+09. What is the difference between the Expenses (in $) in Miscellaneous expenses in 1997 and the Expenses (in $) in Services in 2003?
Give a very brief answer. -1.49e+09. What is the difference between the Expenses (in $) in Labor Taxes in 1997 and the Expenses (in $) in Grants and Revenue in 2003?
Provide a short and direct response. -2.76e+09. What is the difference between the Expenses (in $) in Labor Taxes in 1997 and the Expenses (in $) in Services in 2003?
Your answer should be compact. -1.46e+09. What is the difference between the Expenses (in $) in Grants and Revenue in 1997 and the Expenses (in $) in Services in 2003?
Ensure brevity in your answer.  -3.32e+08. What is the difference between the Expenses (in $) of Miscellaneous expenses in 1997 and the Expenses (in $) of Labor Taxes in 2004?
Offer a terse response. -3.94e+07. What is the difference between the Expenses (in $) of Miscellaneous expenses in 1997 and the Expenses (in $) of Grants and Revenue in 2004?
Make the answer very short. -3.11e+09. What is the difference between the Expenses (in $) of Miscellaneous expenses in 1997 and the Expenses (in $) of Services in 2004?
Provide a short and direct response. -1.57e+09. What is the difference between the Expenses (in $) of Labor Taxes in 1997 and the Expenses (in $) of Grants and Revenue in 2004?
Offer a terse response. -3.08e+09. What is the difference between the Expenses (in $) in Labor Taxes in 1997 and the Expenses (in $) in Services in 2004?
Your answer should be very brief. -1.54e+09. What is the difference between the Expenses (in $) of Grants and Revenue in 1997 and the Expenses (in $) of Services in 2004?
Keep it short and to the point. -4.14e+08. What is the difference between the Expenses (in $) of Miscellaneous expenses in 1998 and the Expenses (in $) of Labor Taxes in 1999?
Your response must be concise. -4.72e+07. What is the difference between the Expenses (in $) in Miscellaneous expenses in 1998 and the Expenses (in $) in Grants and Revenue in 1999?
Your answer should be very brief. -1.05e+09. What is the difference between the Expenses (in $) of Miscellaneous expenses in 1998 and the Expenses (in $) of Services in 1999?
Make the answer very short. -8.52e+08. What is the difference between the Expenses (in $) in Labor Taxes in 1998 and the Expenses (in $) in Grants and Revenue in 1999?
Offer a very short reply. -1.02e+09. What is the difference between the Expenses (in $) of Labor Taxes in 1998 and the Expenses (in $) of Services in 1999?
Make the answer very short. -8.18e+08. What is the difference between the Expenses (in $) in Grants and Revenue in 1998 and the Expenses (in $) in Services in 1999?
Make the answer very short. 4.90e+08. What is the difference between the Expenses (in $) of Miscellaneous expenses in 1998 and the Expenses (in $) of Labor Taxes in 2000?
Make the answer very short. -4.19e+07. What is the difference between the Expenses (in $) of Miscellaneous expenses in 1998 and the Expenses (in $) of Grants and Revenue in 2000?
Your answer should be very brief. -9.95e+08. What is the difference between the Expenses (in $) of Miscellaneous expenses in 1998 and the Expenses (in $) of Services in 2000?
Your answer should be very brief. -8.48e+08. What is the difference between the Expenses (in $) in Labor Taxes in 1998 and the Expenses (in $) in Grants and Revenue in 2000?
Make the answer very short. -9.62e+08. What is the difference between the Expenses (in $) in Labor Taxes in 1998 and the Expenses (in $) in Services in 2000?
Your answer should be very brief. -8.14e+08. What is the difference between the Expenses (in $) of Grants and Revenue in 1998 and the Expenses (in $) of Services in 2000?
Make the answer very short. 4.94e+08. What is the difference between the Expenses (in $) in Miscellaneous expenses in 1998 and the Expenses (in $) in Labor Taxes in 2001?
Provide a short and direct response. -3.55e+07. What is the difference between the Expenses (in $) in Miscellaneous expenses in 1998 and the Expenses (in $) in Grants and Revenue in 2001?
Make the answer very short. -2.13e+09. What is the difference between the Expenses (in $) of Miscellaneous expenses in 1998 and the Expenses (in $) of Services in 2001?
Ensure brevity in your answer.  -1.30e+09. What is the difference between the Expenses (in $) of Labor Taxes in 1998 and the Expenses (in $) of Grants and Revenue in 2001?
Offer a very short reply. -2.09e+09. What is the difference between the Expenses (in $) of Labor Taxes in 1998 and the Expenses (in $) of Services in 2001?
Give a very brief answer. -1.27e+09. What is the difference between the Expenses (in $) in Grants and Revenue in 1998 and the Expenses (in $) in Services in 2001?
Ensure brevity in your answer.  4.21e+07. What is the difference between the Expenses (in $) in Miscellaneous expenses in 1998 and the Expenses (in $) in Labor Taxes in 2002?
Your answer should be compact. -3.74e+07. What is the difference between the Expenses (in $) in Miscellaneous expenses in 1998 and the Expenses (in $) in Grants and Revenue in 2002?
Provide a short and direct response. -2.38e+09. What is the difference between the Expenses (in $) of Miscellaneous expenses in 1998 and the Expenses (in $) of Services in 2002?
Provide a succinct answer. -1.47e+09. What is the difference between the Expenses (in $) of Labor Taxes in 1998 and the Expenses (in $) of Grants and Revenue in 2002?
Provide a short and direct response. -2.35e+09. What is the difference between the Expenses (in $) of Labor Taxes in 1998 and the Expenses (in $) of Services in 2002?
Your answer should be compact. -1.44e+09. What is the difference between the Expenses (in $) of Grants and Revenue in 1998 and the Expenses (in $) of Services in 2002?
Your answer should be compact. -1.30e+08. What is the difference between the Expenses (in $) in Miscellaneous expenses in 1998 and the Expenses (in $) in Labor Taxes in 2003?
Give a very brief answer. -3.85e+07. What is the difference between the Expenses (in $) in Miscellaneous expenses in 1998 and the Expenses (in $) in Grants and Revenue in 2003?
Your answer should be very brief. -2.80e+09. What is the difference between the Expenses (in $) of Miscellaneous expenses in 1998 and the Expenses (in $) of Services in 2003?
Offer a terse response. -1.49e+09. What is the difference between the Expenses (in $) in Labor Taxes in 1998 and the Expenses (in $) in Grants and Revenue in 2003?
Your answer should be very brief. -2.76e+09. What is the difference between the Expenses (in $) of Labor Taxes in 1998 and the Expenses (in $) of Services in 2003?
Keep it short and to the point. -1.46e+09. What is the difference between the Expenses (in $) in Grants and Revenue in 1998 and the Expenses (in $) in Services in 2003?
Your answer should be very brief. -1.48e+08. What is the difference between the Expenses (in $) in Miscellaneous expenses in 1998 and the Expenses (in $) in Labor Taxes in 2004?
Ensure brevity in your answer.  -4.18e+07. What is the difference between the Expenses (in $) in Miscellaneous expenses in 1998 and the Expenses (in $) in Grants and Revenue in 2004?
Ensure brevity in your answer.  -3.11e+09. What is the difference between the Expenses (in $) in Miscellaneous expenses in 1998 and the Expenses (in $) in Services in 2004?
Ensure brevity in your answer.  -1.57e+09. What is the difference between the Expenses (in $) of Labor Taxes in 1998 and the Expenses (in $) of Grants and Revenue in 2004?
Your response must be concise. -3.08e+09. What is the difference between the Expenses (in $) of Labor Taxes in 1998 and the Expenses (in $) of Services in 2004?
Make the answer very short. -1.54e+09. What is the difference between the Expenses (in $) in Grants and Revenue in 1998 and the Expenses (in $) in Services in 2004?
Provide a short and direct response. -2.30e+08. What is the difference between the Expenses (in $) in Miscellaneous expenses in 1999 and the Expenses (in $) in Labor Taxes in 2000?
Your answer should be very brief. -4.14e+07. What is the difference between the Expenses (in $) in Miscellaneous expenses in 1999 and the Expenses (in $) in Grants and Revenue in 2000?
Offer a very short reply. -9.94e+08. What is the difference between the Expenses (in $) of Miscellaneous expenses in 1999 and the Expenses (in $) of Services in 2000?
Your answer should be compact. -8.47e+08. What is the difference between the Expenses (in $) in Labor Taxes in 1999 and the Expenses (in $) in Grants and Revenue in 2000?
Your response must be concise. -9.48e+08. What is the difference between the Expenses (in $) in Labor Taxes in 1999 and the Expenses (in $) in Services in 2000?
Your response must be concise. -8.01e+08. What is the difference between the Expenses (in $) of Grants and Revenue in 1999 and the Expenses (in $) of Services in 2000?
Provide a succinct answer. 2.06e+08. What is the difference between the Expenses (in $) in Miscellaneous expenses in 1999 and the Expenses (in $) in Labor Taxes in 2001?
Give a very brief answer. -3.50e+07. What is the difference between the Expenses (in $) of Miscellaneous expenses in 1999 and the Expenses (in $) of Grants and Revenue in 2001?
Your answer should be compact. -2.13e+09. What is the difference between the Expenses (in $) of Miscellaneous expenses in 1999 and the Expenses (in $) of Services in 2001?
Keep it short and to the point. -1.30e+09. What is the difference between the Expenses (in $) of Labor Taxes in 1999 and the Expenses (in $) of Grants and Revenue in 2001?
Offer a terse response. -2.08e+09. What is the difference between the Expenses (in $) in Labor Taxes in 1999 and the Expenses (in $) in Services in 2001?
Your answer should be compact. -1.25e+09. What is the difference between the Expenses (in $) in Grants and Revenue in 1999 and the Expenses (in $) in Services in 2001?
Your answer should be compact. -2.46e+08. What is the difference between the Expenses (in $) of Miscellaneous expenses in 1999 and the Expenses (in $) of Labor Taxes in 2002?
Provide a short and direct response. -3.69e+07. What is the difference between the Expenses (in $) of Miscellaneous expenses in 1999 and the Expenses (in $) of Grants and Revenue in 2002?
Offer a very short reply. -2.38e+09. What is the difference between the Expenses (in $) of Miscellaneous expenses in 1999 and the Expenses (in $) of Services in 2002?
Offer a terse response. -1.47e+09. What is the difference between the Expenses (in $) in Labor Taxes in 1999 and the Expenses (in $) in Grants and Revenue in 2002?
Give a very brief answer. -2.33e+09. What is the difference between the Expenses (in $) in Labor Taxes in 1999 and the Expenses (in $) in Services in 2002?
Make the answer very short. -1.43e+09. What is the difference between the Expenses (in $) of Grants and Revenue in 1999 and the Expenses (in $) of Services in 2002?
Provide a short and direct response. -4.18e+08. What is the difference between the Expenses (in $) in Miscellaneous expenses in 1999 and the Expenses (in $) in Labor Taxes in 2003?
Provide a succinct answer. -3.80e+07. What is the difference between the Expenses (in $) in Miscellaneous expenses in 1999 and the Expenses (in $) in Grants and Revenue in 2003?
Ensure brevity in your answer.  -2.80e+09. What is the difference between the Expenses (in $) in Miscellaneous expenses in 1999 and the Expenses (in $) in Services in 2003?
Ensure brevity in your answer.  -1.49e+09. What is the difference between the Expenses (in $) of Labor Taxes in 1999 and the Expenses (in $) of Grants and Revenue in 2003?
Your answer should be very brief. -2.75e+09. What is the difference between the Expenses (in $) of Labor Taxes in 1999 and the Expenses (in $) of Services in 2003?
Your response must be concise. -1.44e+09. What is the difference between the Expenses (in $) of Grants and Revenue in 1999 and the Expenses (in $) of Services in 2003?
Offer a very short reply. -4.36e+08. What is the difference between the Expenses (in $) of Miscellaneous expenses in 1999 and the Expenses (in $) of Labor Taxes in 2004?
Ensure brevity in your answer.  -4.13e+07. What is the difference between the Expenses (in $) in Miscellaneous expenses in 1999 and the Expenses (in $) in Grants and Revenue in 2004?
Provide a short and direct response. -3.11e+09. What is the difference between the Expenses (in $) of Miscellaneous expenses in 1999 and the Expenses (in $) of Services in 2004?
Offer a very short reply. -1.57e+09. What is the difference between the Expenses (in $) in Labor Taxes in 1999 and the Expenses (in $) in Grants and Revenue in 2004?
Ensure brevity in your answer.  -3.07e+09. What is the difference between the Expenses (in $) of Labor Taxes in 1999 and the Expenses (in $) of Services in 2004?
Give a very brief answer. -1.52e+09. What is the difference between the Expenses (in $) in Grants and Revenue in 1999 and the Expenses (in $) in Services in 2004?
Offer a terse response. -5.18e+08. What is the difference between the Expenses (in $) in Miscellaneous expenses in 2000 and the Expenses (in $) in Labor Taxes in 2001?
Offer a very short reply. 1.44e+07. What is the difference between the Expenses (in $) in Miscellaneous expenses in 2000 and the Expenses (in $) in Grants and Revenue in 2001?
Make the answer very short. -2.08e+09. What is the difference between the Expenses (in $) of Miscellaneous expenses in 2000 and the Expenses (in $) of Services in 2001?
Keep it short and to the point. -1.25e+09. What is the difference between the Expenses (in $) in Labor Taxes in 2000 and the Expenses (in $) in Grants and Revenue in 2001?
Keep it short and to the point. -2.08e+09. What is the difference between the Expenses (in $) in Labor Taxes in 2000 and the Expenses (in $) in Services in 2001?
Offer a terse response. -1.26e+09. What is the difference between the Expenses (in $) in Grants and Revenue in 2000 and the Expenses (in $) in Services in 2001?
Your answer should be compact. -3.05e+08. What is the difference between the Expenses (in $) in Miscellaneous expenses in 2000 and the Expenses (in $) in Labor Taxes in 2002?
Provide a succinct answer. 1.25e+07. What is the difference between the Expenses (in $) of Miscellaneous expenses in 2000 and the Expenses (in $) of Grants and Revenue in 2002?
Offer a very short reply. -2.33e+09. What is the difference between the Expenses (in $) in Miscellaneous expenses in 2000 and the Expenses (in $) in Services in 2002?
Ensure brevity in your answer.  -1.42e+09. What is the difference between the Expenses (in $) in Labor Taxes in 2000 and the Expenses (in $) in Grants and Revenue in 2002?
Your answer should be compact. -2.34e+09. What is the difference between the Expenses (in $) in Labor Taxes in 2000 and the Expenses (in $) in Services in 2002?
Offer a terse response. -1.43e+09. What is the difference between the Expenses (in $) of Grants and Revenue in 2000 and the Expenses (in $) of Services in 2002?
Your response must be concise. -4.77e+08. What is the difference between the Expenses (in $) of Miscellaneous expenses in 2000 and the Expenses (in $) of Labor Taxes in 2003?
Provide a short and direct response. 1.14e+07. What is the difference between the Expenses (in $) of Miscellaneous expenses in 2000 and the Expenses (in $) of Grants and Revenue in 2003?
Provide a succinct answer. -2.75e+09. What is the difference between the Expenses (in $) in Miscellaneous expenses in 2000 and the Expenses (in $) in Services in 2003?
Ensure brevity in your answer.  -1.44e+09. What is the difference between the Expenses (in $) in Labor Taxes in 2000 and the Expenses (in $) in Grants and Revenue in 2003?
Offer a very short reply. -2.76e+09. What is the difference between the Expenses (in $) in Labor Taxes in 2000 and the Expenses (in $) in Services in 2003?
Offer a very short reply. -1.45e+09. What is the difference between the Expenses (in $) of Grants and Revenue in 2000 and the Expenses (in $) of Services in 2003?
Offer a very short reply. -4.95e+08. What is the difference between the Expenses (in $) of Miscellaneous expenses in 2000 and the Expenses (in $) of Labor Taxes in 2004?
Provide a succinct answer. 8.10e+06. What is the difference between the Expenses (in $) of Miscellaneous expenses in 2000 and the Expenses (in $) of Grants and Revenue in 2004?
Provide a succinct answer. -3.06e+09. What is the difference between the Expenses (in $) in Miscellaneous expenses in 2000 and the Expenses (in $) in Services in 2004?
Keep it short and to the point. -1.52e+09. What is the difference between the Expenses (in $) in Labor Taxes in 2000 and the Expenses (in $) in Grants and Revenue in 2004?
Keep it short and to the point. -3.07e+09. What is the difference between the Expenses (in $) in Labor Taxes in 2000 and the Expenses (in $) in Services in 2004?
Give a very brief answer. -1.53e+09. What is the difference between the Expenses (in $) in Grants and Revenue in 2000 and the Expenses (in $) in Services in 2004?
Make the answer very short. -5.77e+08. What is the difference between the Expenses (in $) of Miscellaneous expenses in 2001 and the Expenses (in $) of Labor Taxes in 2002?
Make the answer very short. -5.00e+06. What is the difference between the Expenses (in $) in Miscellaneous expenses in 2001 and the Expenses (in $) in Grants and Revenue in 2002?
Keep it short and to the point. -2.35e+09. What is the difference between the Expenses (in $) in Miscellaneous expenses in 2001 and the Expenses (in $) in Services in 2002?
Your answer should be very brief. -1.44e+09. What is the difference between the Expenses (in $) in Labor Taxes in 2001 and the Expenses (in $) in Grants and Revenue in 2002?
Your answer should be compact. -2.35e+09. What is the difference between the Expenses (in $) in Labor Taxes in 2001 and the Expenses (in $) in Services in 2002?
Your answer should be very brief. -1.44e+09. What is the difference between the Expenses (in $) of Grants and Revenue in 2001 and the Expenses (in $) of Services in 2002?
Your response must be concise. 6.54e+08. What is the difference between the Expenses (in $) in Miscellaneous expenses in 2001 and the Expenses (in $) in Labor Taxes in 2003?
Your answer should be compact. -6.10e+06. What is the difference between the Expenses (in $) in Miscellaneous expenses in 2001 and the Expenses (in $) in Grants and Revenue in 2003?
Give a very brief answer. -2.77e+09. What is the difference between the Expenses (in $) of Miscellaneous expenses in 2001 and the Expenses (in $) of Services in 2003?
Offer a terse response. -1.46e+09. What is the difference between the Expenses (in $) in Labor Taxes in 2001 and the Expenses (in $) in Grants and Revenue in 2003?
Your answer should be very brief. -2.76e+09. What is the difference between the Expenses (in $) in Labor Taxes in 2001 and the Expenses (in $) in Services in 2003?
Your answer should be compact. -1.45e+09. What is the difference between the Expenses (in $) in Grants and Revenue in 2001 and the Expenses (in $) in Services in 2003?
Your answer should be compact. 6.37e+08. What is the difference between the Expenses (in $) of Miscellaneous expenses in 2001 and the Expenses (in $) of Labor Taxes in 2004?
Make the answer very short. -9.40e+06. What is the difference between the Expenses (in $) in Miscellaneous expenses in 2001 and the Expenses (in $) in Grants and Revenue in 2004?
Ensure brevity in your answer.  -3.08e+09. What is the difference between the Expenses (in $) of Miscellaneous expenses in 2001 and the Expenses (in $) of Services in 2004?
Give a very brief answer. -1.54e+09. What is the difference between the Expenses (in $) of Labor Taxes in 2001 and the Expenses (in $) of Grants and Revenue in 2004?
Make the answer very short. -3.08e+09. What is the difference between the Expenses (in $) in Labor Taxes in 2001 and the Expenses (in $) in Services in 2004?
Keep it short and to the point. -1.54e+09. What is the difference between the Expenses (in $) in Grants and Revenue in 2001 and the Expenses (in $) in Services in 2004?
Provide a succinct answer. 5.55e+08. What is the difference between the Expenses (in $) in Miscellaneous expenses in 2002 and the Expenses (in $) in Labor Taxes in 2003?
Keep it short and to the point. -5.50e+06. What is the difference between the Expenses (in $) in Miscellaneous expenses in 2002 and the Expenses (in $) in Grants and Revenue in 2003?
Your answer should be very brief. -2.77e+09. What is the difference between the Expenses (in $) in Miscellaneous expenses in 2002 and the Expenses (in $) in Services in 2003?
Ensure brevity in your answer.  -1.46e+09. What is the difference between the Expenses (in $) in Labor Taxes in 2002 and the Expenses (in $) in Grants and Revenue in 2003?
Provide a succinct answer. -2.76e+09. What is the difference between the Expenses (in $) of Labor Taxes in 2002 and the Expenses (in $) of Services in 2003?
Give a very brief answer. -1.45e+09. What is the difference between the Expenses (in $) in Grants and Revenue in 2002 and the Expenses (in $) in Services in 2003?
Offer a very short reply. 8.90e+08. What is the difference between the Expenses (in $) of Miscellaneous expenses in 2002 and the Expenses (in $) of Labor Taxes in 2004?
Keep it short and to the point. -8.80e+06. What is the difference between the Expenses (in $) in Miscellaneous expenses in 2002 and the Expenses (in $) in Grants and Revenue in 2004?
Make the answer very short. -3.08e+09. What is the difference between the Expenses (in $) in Miscellaneous expenses in 2002 and the Expenses (in $) in Services in 2004?
Offer a very short reply. -1.54e+09. What is the difference between the Expenses (in $) of Labor Taxes in 2002 and the Expenses (in $) of Grants and Revenue in 2004?
Your answer should be compact. -3.08e+09. What is the difference between the Expenses (in $) of Labor Taxes in 2002 and the Expenses (in $) of Services in 2004?
Provide a succinct answer. -1.53e+09. What is the difference between the Expenses (in $) in Grants and Revenue in 2002 and the Expenses (in $) in Services in 2004?
Your answer should be very brief. 8.09e+08. What is the difference between the Expenses (in $) of Miscellaneous expenses in 2003 and the Expenses (in $) of Labor Taxes in 2004?
Make the answer very short. -4.00e+05. What is the difference between the Expenses (in $) in Miscellaneous expenses in 2003 and the Expenses (in $) in Grants and Revenue in 2004?
Make the answer very short. -3.07e+09. What is the difference between the Expenses (in $) in Miscellaneous expenses in 2003 and the Expenses (in $) in Services in 2004?
Offer a terse response. -1.53e+09. What is the difference between the Expenses (in $) in Labor Taxes in 2003 and the Expenses (in $) in Grants and Revenue in 2004?
Give a very brief answer. -3.07e+09. What is the difference between the Expenses (in $) in Labor Taxes in 2003 and the Expenses (in $) in Services in 2004?
Ensure brevity in your answer.  -1.53e+09. What is the difference between the Expenses (in $) in Grants and Revenue in 2003 and the Expenses (in $) in Services in 2004?
Your response must be concise. 1.23e+09. What is the average Expenses (in $) in Miscellaneous expenses per year?
Your answer should be compact. 2.48e+07. What is the average Expenses (in $) in Labor Taxes per year?
Keep it short and to the point. 3.85e+07. What is the average Expenses (in $) of Grants and Revenue per year?
Give a very brief answer. 1.79e+09. What is the average Expenses (in $) in Services per year?
Ensure brevity in your answer.  1.15e+09. In the year 1996, what is the difference between the Expenses (in $) of Miscellaneous expenses and Expenses (in $) of Labor Taxes?
Provide a short and direct response. -2.37e+07. In the year 1996, what is the difference between the Expenses (in $) of Miscellaneous expenses and Expenses (in $) of Grants and Revenue?
Your response must be concise. -1.09e+09. In the year 1996, what is the difference between the Expenses (in $) in Miscellaneous expenses and Expenses (in $) in Services?
Your response must be concise. -9.38e+08. In the year 1996, what is the difference between the Expenses (in $) of Labor Taxes and Expenses (in $) of Grants and Revenue?
Give a very brief answer. -1.07e+09. In the year 1996, what is the difference between the Expenses (in $) of Labor Taxes and Expenses (in $) of Services?
Your response must be concise. -9.14e+08. In the year 1996, what is the difference between the Expenses (in $) of Grants and Revenue and Expenses (in $) of Services?
Offer a very short reply. 1.54e+08. In the year 1997, what is the difference between the Expenses (in $) in Miscellaneous expenses and Expenses (in $) in Labor Taxes?
Offer a very short reply. -3.11e+07. In the year 1997, what is the difference between the Expenses (in $) of Miscellaneous expenses and Expenses (in $) of Grants and Revenue?
Ensure brevity in your answer.  -1.16e+09. In the year 1997, what is the difference between the Expenses (in $) of Miscellaneous expenses and Expenses (in $) of Services?
Ensure brevity in your answer.  -8.92e+08. In the year 1997, what is the difference between the Expenses (in $) in Labor Taxes and Expenses (in $) in Grants and Revenue?
Your response must be concise. -1.12e+09. In the year 1997, what is the difference between the Expenses (in $) of Labor Taxes and Expenses (in $) of Services?
Make the answer very short. -8.61e+08. In the year 1997, what is the difference between the Expenses (in $) in Grants and Revenue and Expenses (in $) in Services?
Offer a very short reply. 2.63e+08. In the year 1998, what is the difference between the Expenses (in $) in Miscellaneous expenses and Expenses (in $) in Labor Taxes?
Your answer should be very brief. -3.34e+07. In the year 1998, what is the difference between the Expenses (in $) of Miscellaneous expenses and Expenses (in $) of Grants and Revenue?
Offer a terse response. -1.34e+09. In the year 1998, what is the difference between the Expenses (in $) of Miscellaneous expenses and Expenses (in $) of Services?
Your response must be concise. -9.24e+08. In the year 1998, what is the difference between the Expenses (in $) of Labor Taxes and Expenses (in $) of Grants and Revenue?
Provide a succinct answer. -1.31e+09. In the year 1998, what is the difference between the Expenses (in $) of Labor Taxes and Expenses (in $) of Services?
Your answer should be very brief. -8.91e+08. In the year 1998, what is the difference between the Expenses (in $) in Grants and Revenue and Expenses (in $) in Services?
Offer a very short reply. 4.18e+08. In the year 1999, what is the difference between the Expenses (in $) in Miscellaneous expenses and Expenses (in $) in Labor Taxes?
Your answer should be compact. -4.67e+07. In the year 1999, what is the difference between the Expenses (in $) of Miscellaneous expenses and Expenses (in $) of Grants and Revenue?
Provide a short and direct response. -1.05e+09. In the year 1999, what is the difference between the Expenses (in $) in Miscellaneous expenses and Expenses (in $) in Services?
Offer a terse response. -8.51e+08. In the year 1999, what is the difference between the Expenses (in $) of Labor Taxes and Expenses (in $) of Grants and Revenue?
Give a very brief answer. -1.01e+09. In the year 1999, what is the difference between the Expenses (in $) of Labor Taxes and Expenses (in $) of Services?
Your response must be concise. -8.05e+08. In the year 1999, what is the difference between the Expenses (in $) in Grants and Revenue and Expenses (in $) in Services?
Provide a short and direct response. 2.02e+08. In the year 2000, what is the difference between the Expenses (in $) in Miscellaneous expenses and Expenses (in $) in Labor Taxes?
Offer a terse response. 8.00e+06. In the year 2000, what is the difference between the Expenses (in $) in Miscellaneous expenses and Expenses (in $) in Grants and Revenue?
Provide a short and direct response. -9.45e+08. In the year 2000, what is the difference between the Expenses (in $) of Miscellaneous expenses and Expenses (in $) of Services?
Offer a terse response. -7.98e+08. In the year 2000, what is the difference between the Expenses (in $) of Labor Taxes and Expenses (in $) of Grants and Revenue?
Give a very brief answer. -9.53e+08. In the year 2000, what is the difference between the Expenses (in $) of Labor Taxes and Expenses (in $) of Services?
Your answer should be very brief. -8.06e+08. In the year 2000, what is the difference between the Expenses (in $) in Grants and Revenue and Expenses (in $) in Services?
Keep it short and to the point. 1.47e+08. In the year 2001, what is the difference between the Expenses (in $) of Miscellaneous expenses and Expenses (in $) of Labor Taxes?
Give a very brief answer. -3.10e+06. In the year 2001, what is the difference between the Expenses (in $) in Miscellaneous expenses and Expenses (in $) in Grants and Revenue?
Give a very brief answer. -2.09e+09. In the year 2001, what is the difference between the Expenses (in $) in Miscellaneous expenses and Expenses (in $) in Services?
Keep it short and to the point. -1.27e+09. In the year 2001, what is the difference between the Expenses (in $) in Labor Taxes and Expenses (in $) in Grants and Revenue?
Your answer should be compact. -2.09e+09. In the year 2001, what is the difference between the Expenses (in $) in Labor Taxes and Expenses (in $) in Services?
Your answer should be very brief. -1.26e+09. In the year 2001, what is the difference between the Expenses (in $) of Grants and Revenue and Expenses (in $) of Services?
Ensure brevity in your answer.  8.27e+08. In the year 2002, what is the difference between the Expenses (in $) in Miscellaneous expenses and Expenses (in $) in Labor Taxes?
Provide a succinct answer. -4.40e+06. In the year 2002, what is the difference between the Expenses (in $) in Miscellaneous expenses and Expenses (in $) in Grants and Revenue?
Your response must be concise. -2.35e+09. In the year 2002, what is the difference between the Expenses (in $) of Miscellaneous expenses and Expenses (in $) of Services?
Your answer should be compact. -1.44e+09. In the year 2002, what is the difference between the Expenses (in $) of Labor Taxes and Expenses (in $) of Grants and Revenue?
Provide a succinct answer. -2.34e+09. In the year 2002, what is the difference between the Expenses (in $) of Labor Taxes and Expenses (in $) of Services?
Give a very brief answer. -1.43e+09. In the year 2002, what is the difference between the Expenses (in $) of Grants and Revenue and Expenses (in $) of Services?
Your answer should be compact. 9.08e+08. In the year 2003, what is the difference between the Expenses (in $) in Miscellaneous expenses and Expenses (in $) in Labor Taxes?
Provide a succinct answer. 2.90e+06. In the year 2003, what is the difference between the Expenses (in $) of Miscellaneous expenses and Expenses (in $) of Grants and Revenue?
Offer a terse response. -2.76e+09. In the year 2003, what is the difference between the Expenses (in $) in Miscellaneous expenses and Expenses (in $) in Services?
Make the answer very short. -1.45e+09. In the year 2003, what is the difference between the Expenses (in $) in Labor Taxes and Expenses (in $) in Grants and Revenue?
Provide a succinct answer. -2.76e+09. In the year 2003, what is the difference between the Expenses (in $) of Labor Taxes and Expenses (in $) of Services?
Your response must be concise. -1.45e+09. In the year 2003, what is the difference between the Expenses (in $) of Grants and Revenue and Expenses (in $) of Services?
Offer a very short reply. 1.31e+09. In the year 2004, what is the difference between the Expenses (in $) in Miscellaneous expenses and Expenses (in $) in Labor Taxes?
Your answer should be compact. 8.10e+06. In the year 2004, what is the difference between the Expenses (in $) of Miscellaneous expenses and Expenses (in $) of Grants and Revenue?
Offer a very short reply. -3.06e+09. In the year 2004, what is the difference between the Expenses (in $) in Miscellaneous expenses and Expenses (in $) in Services?
Give a very brief answer. -1.52e+09. In the year 2004, what is the difference between the Expenses (in $) of Labor Taxes and Expenses (in $) of Grants and Revenue?
Your response must be concise. -3.07e+09. In the year 2004, what is the difference between the Expenses (in $) of Labor Taxes and Expenses (in $) of Services?
Give a very brief answer. -1.53e+09. In the year 2004, what is the difference between the Expenses (in $) of Grants and Revenue and Expenses (in $) of Services?
Your answer should be very brief. 1.54e+09. What is the ratio of the Expenses (in $) in Miscellaneous expenses in 1996 to that in 1997?
Ensure brevity in your answer.  0.86. What is the ratio of the Expenses (in $) in Labor Taxes in 1996 to that in 1997?
Ensure brevity in your answer.  0.77. What is the ratio of the Expenses (in $) in Grants and Revenue in 1996 to that in 1997?
Ensure brevity in your answer.  0.94. What is the ratio of the Expenses (in $) in Services in 1996 to that in 1997?
Your answer should be compact. 1.05. What is the ratio of the Expenses (in $) in Miscellaneous expenses in 1996 to that in 1998?
Give a very brief answer. 2.46. What is the ratio of the Expenses (in $) in Labor Taxes in 1996 to that in 1998?
Your answer should be very brief. 0.78. What is the ratio of the Expenses (in $) in Grants and Revenue in 1996 to that in 1998?
Your answer should be very brief. 0.82. What is the ratio of the Expenses (in $) in Services in 1996 to that in 1998?
Ensure brevity in your answer.  1.02. What is the ratio of the Expenses (in $) in Miscellaneous expenses in 1996 to that in 1999?
Keep it short and to the point. 1.78. What is the ratio of the Expenses (in $) in Labor Taxes in 1996 to that in 1999?
Keep it short and to the point. 0.55. What is the ratio of the Expenses (in $) in Grants and Revenue in 1996 to that in 1999?
Provide a succinct answer. 1.04. What is the ratio of the Expenses (in $) in Services in 1996 to that in 1999?
Give a very brief answer. 1.1. What is the ratio of the Expenses (in $) of Miscellaneous expenses in 1996 to that in 2000?
Offer a terse response. 0.06. What is the ratio of the Expenses (in $) in Labor Taxes in 1996 to that in 2000?
Keep it short and to the point. 0.62. What is the ratio of the Expenses (in $) in Grants and Revenue in 1996 to that in 2000?
Make the answer very short. 1.1. What is the ratio of the Expenses (in $) in Services in 1996 to that in 2000?
Your answer should be very brief. 1.11. What is the ratio of the Expenses (in $) of Miscellaneous expenses in 1996 to that in 2001?
Your answer should be very brief. 0.1. What is the ratio of the Expenses (in $) of Labor Taxes in 1996 to that in 2001?
Keep it short and to the point. 0.73. What is the ratio of the Expenses (in $) in Grants and Revenue in 1996 to that in 2001?
Make the answer very short. 0.51. What is the ratio of the Expenses (in $) of Services in 1996 to that in 2001?
Make the answer very short. 0.72. What is the ratio of the Expenses (in $) in Miscellaneous expenses in 1996 to that in 2002?
Ensure brevity in your answer.  0.09. What is the ratio of the Expenses (in $) in Labor Taxes in 1996 to that in 2002?
Ensure brevity in your answer.  0.7. What is the ratio of the Expenses (in $) in Grants and Revenue in 1996 to that in 2002?
Give a very brief answer. 0.46. What is the ratio of the Expenses (in $) of Services in 1996 to that in 2002?
Provide a succinct answer. 0.64. What is the ratio of the Expenses (in $) in Miscellaneous expenses in 1996 to that in 2003?
Your answer should be very brief. 0.07. What is the ratio of the Expenses (in $) in Labor Taxes in 1996 to that in 2003?
Provide a succinct answer. 0.68. What is the ratio of the Expenses (in $) of Grants and Revenue in 1996 to that in 2003?
Provide a short and direct response. 0.39. What is the ratio of the Expenses (in $) of Services in 1996 to that in 2003?
Keep it short and to the point. 0.63. What is the ratio of the Expenses (in $) in Miscellaneous expenses in 1996 to that in 2004?
Your response must be concise. 0.06. What is the ratio of the Expenses (in $) in Labor Taxes in 1996 to that in 2004?
Keep it short and to the point. 0.62. What is the ratio of the Expenses (in $) of Grants and Revenue in 1996 to that in 2004?
Ensure brevity in your answer.  0.35. What is the ratio of the Expenses (in $) in Services in 1996 to that in 2004?
Give a very brief answer. 0.6. What is the ratio of the Expenses (in $) of Miscellaneous expenses in 1997 to that in 1998?
Make the answer very short. 2.85. What is the ratio of the Expenses (in $) in Labor Taxes in 1997 to that in 1998?
Offer a very short reply. 1. What is the ratio of the Expenses (in $) in Grants and Revenue in 1997 to that in 1998?
Offer a terse response. 0.86. What is the ratio of the Expenses (in $) in Services in 1997 to that in 1998?
Provide a succinct answer. 0.97. What is the ratio of the Expenses (in $) of Miscellaneous expenses in 1997 to that in 1999?
Your response must be concise. 2.06. What is the ratio of the Expenses (in $) in Labor Taxes in 1997 to that in 1999?
Keep it short and to the point. 0.72. What is the ratio of the Expenses (in $) in Grants and Revenue in 1997 to that in 1999?
Your response must be concise. 1.1. What is the ratio of the Expenses (in $) of Services in 1997 to that in 1999?
Offer a terse response. 1.05. What is the ratio of the Expenses (in $) in Miscellaneous expenses in 1997 to that in 2000?
Keep it short and to the point. 0.07. What is the ratio of the Expenses (in $) of Labor Taxes in 1997 to that in 2000?
Keep it short and to the point. 0.81. What is the ratio of the Expenses (in $) of Grants and Revenue in 1997 to that in 2000?
Give a very brief answer. 1.16. What is the ratio of the Expenses (in $) of Services in 1997 to that in 2000?
Provide a short and direct response. 1.06. What is the ratio of the Expenses (in $) in Miscellaneous expenses in 1997 to that in 2001?
Give a very brief answer. 0.11. What is the ratio of the Expenses (in $) in Labor Taxes in 1997 to that in 2001?
Provide a short and direct response. 0.95. What is the ratio of the Expenses (in $) in Grants and Revenue in 1997 to that in 2001?
Make the answer very short. 0.54. What is the ratio of the Expenses (in $) of Services in 1997 to that in 2001?
Your answer should be compact. 0.69. What is the ratio of the Expenses (in $) of Miscellaneous expenses in 1997 to that in 2002?
Provide a succinct answer. 0.11. What is the ratio of the Expenses (in $) of Labor Taxes in 1997 to that in 2002?
Ensure brevity in your answer.  0.9. What is the ratio of the Expenses (in $) in Grants and Revenue in 1997 to that in 2002?
Provide a succinct answer. 0.49. What is the ratio of the Expenses (in $) of Services in 1997 to that in 2002?
Give a very brief answer. 0.61. What is the ratio of the Expenses (in $) of Miscellaneous expenses in 1997 to that in 2003?
Make the answer very short. 0.09. What is the ratio of the Expenses (in $) of Labor Taxes in 1997 to that in 2003?
Ensure brevity in your answer.  0.87. What is the ratio of the Expenses (in $) of Grants and Revenue in 1997 to that in 2003?
Provide a succinct answer. 0.41. What is the ratio of the Expenses (in $) in Services in 1997 to that in 2003?
Your answer should be compact. 0.6. What is the ratio of the Expenses (in $) of Miscellaneous expenses in 1997 to that in 2004?
Offer a very short reply. 0.07. What is the ratio of the Expenses (in $) of Labor Taxes in 1997 to that in 2004?
Offer a terse response. 0.81. What is the ratio of the Expenses (in $) in Grants and Revenue in 1997 to that in 2004?
Ensure brevity in your answer.  0.37. What is the ratio of the Expenses (in $) of Services in 1997 to that in 2004?
Your response must be concise. 0.57. What is the ratio of the Expenses (in $) in Miscellaneous expenses in 1998 to that in 1999?
Make the answer very short. 0.72. What is the ratio of the Expenses (in $) in Labor Taxes in 1998 to that in 1999?
Your answer should be very brief. 0.72. What is the ratio of the Expenses (in $) in Grants and Revenue in 1998 to that in 1999?
Offer a terse response. 1.27. What is the ratio of the Expenses (in $) of Services in 1998 to that in 1999?
Provide a short and direct response. 1.09. What is the ratio of the Expenses (in $) in Miscellaneous expenses in 1998 to that in 2000?
Ensure brevity in your answer.  0.03. What is the ratio of the Expenses (in $) in Labor Taxes in 1998 to that in 2000?
Offer a terse response. 0.8. What is the ratio of the Expenses (in $) in Grants and Revenue in 1998 to that in 2000?
Your answer should be compact. 1.35. What is the ratio of the Expenses (in $) in Services in 1998 to that in 2000?
Offer a terse response. 1.09. What is the ratio of the Expenses (in $) of Miscellaneous expenses in 1998 to that in 2001?
Ensure brevity in your answer.  0.04. What is the ratio of the Expenses (in $) of Labor Taxes in 1998 to that in 2001?
Offer a terse response. 0.94. What is the ratio of the Expenses (in $) in Grants and Revenue in 1998 to that in 2001?
Your response must be concise. 0.63. What is the ratio of the Expenses (in $) in Services in 1998 to that in 2001?
Provide a succinct answer. 0.71. What is the ratio of the Expenses (in $) of Miscellaneous expenses in 1998 to that in 2002?
Offer a terse response. 0.04. What is the ratio of the Expenses (in $) of Labor Taxes in 1998 to that in 2002?
Offer a very short reply. 0.9. What is the ratio of the Expenses (in $) of Grants and Revenue in 1998 to that in 2002?
Provide a short and direct response. 0.56. What is the ratio of the Expenses (in $) of Services in 1998 to that in 2002?
Offer a terse response. 0.63. What is the ratio of the Expenses (in $) of Miscellaneous expenses in 1998 to that in 2003?
Keep it short and to the point. 0.03. What is the ratio of the Expenses (in $) in Labor Taxes in 1998 to that in 2003?
Keep it short and to the point. 0.87. What is the ratio of the Expenses (in $) of Grants and Revenue in 1998 to that in 2003?
Give a very brief answer. 0.48. What is the ratio of the Expenses (in $) in Services in 1998 to that in 2003?
Your answer should be very brief. 0.62. What is the ratio of the Expenses (in $) in Miscellaneous expenses in 1998 to that in 2004?
Keep it short and to the point. 0.03. What is the ratio of the Expenses (in $) of Labor Taxes in 1998 to that in 2004?
Offer a very short reply. 0.81. What is the ratio of the Expenses (in $) of Grants and Revenue in 1998 to that in 2004?
Give a very brief answer. 0.43. What is the ratio of the Expenses (in $) of Services in 1998 to that in 2004?
Keep it short and to the point. 0.59. What is the ratio of the Expenses (in $) in Miscellaneous expenses in 1999 to that in 2000?
Make the answer very short. 0.04. What is the ratio of the Expenses (in $) of Labor Taxes in 1999 to that in 2000?
Offer a very short reply. 1.12. What is the ratio of the Expenses (in $) of Grants and Revenue in 1999 to that in 2000?
Offer a terse response. 1.06. What is the ratio of the Expenses (in $) in Services in 1999 to that in 2000?
Keep it short and to the point. 1. What is the ratio of the Expenses (in $) in Miscellaneous expenses in 1999 to that in 2001?
Keep it short and to the point. 0.05. What is the ratio of the Expenses (in $) of Labor Taxes in 1999 to that in 2001?
Your response must be concise. 1.32. What is the ratio of the Expenses (in $) in Grants and Revenue in 1999 to that in 2001?
Ensure brevity in your answer.  0.5. What is the ratio of the Expenses (in $) in Services in 1999 to that in 2001?
Provide a succinct answer. 0.66. What is the ratio of the Expenses (in $) of Miscellaneous expenses in 1999 to that in 2002?
Provide a succinct answer. 0.05. What is the ratio of the Expenses (in $) in Labor Taxes in 1999 to that in 2002?
Provide a succinct answer. 1.25. What is the ratio of the Expenses (in $) in Grants and Revenue in 1999 to that in 2002?
Your answer should be compact. 0.44. What is the ratio of the Expenses (in $) in Services in 1999 to that in 2002?
Make the answer very short. 0.58. What is the ratio of the Expenses (in $) of Miscellaneous expenses in 1999 to that in 2003?
Make the answer very short. 0.04. What is the ratio of the Expenses (in $) of Labor Taxes in 1999 to that in 2003?
Your response must be concise. 1.22. What is the ratio of the Expenses (in $) in Grants and Revenue in 1999 to that in 2003?
Provide a short and direct response. 0.38. What is the ratio of the Expenses (in $) of Services in 1999 to that in 2003?
Your response must be concise. 0.57. What is the ratio of the Expenses (in $) of Miscellaneous expenses in 1999 to that in 2004?
Your answer should be very brief. 0.04. What is the ratio of the Expenses (in $) of Labor Taxes in 1999 to that in 2004?
Provide a succinct answer. 1.13. What is the ratio of the Expenses (in $) of Grants and Revenue in 1999 to that in 2004?
Your answer should be very brief. 0.34. What is the ratio of the Expenses (in $) of Services in 1999 to that in 2004?
Offer a terse response. 0.54. What is the ratio of the Expenses (in $) in Miscellaneous expenses in 2000 to that in 2001?
Offer a very short reply. 1.52. What is the ratio of the Expenses (in $) in Labor Taxes in 2000 to that in 2001?
Provide a succinct answer. 1.17. What is the ratio of the Expenses (in $) in Grants and Revenue in 2000 to that in 2001?
Your answer should be compact. 0.47. What is the ratio of the Expenses (in $) in Services in 2000 to that in 2001?
Provide a short and direct response. 0.65. What is the ratio of the Expenses (in $) of Miscellaneous expenses in 2000 to that in 2002?
Your answer should be compact. 1.49. What is the ratio of the Expenses (in $) in Labor Taxes in 2000 to that in 2002?
Offer a very short reply. 1.12. What is the ratio of the Expenses (in $) of Grants and Revenue in 2000 to that in 2002?
Your answer should be compact. 0.42. What is the ratio of the Expenses (in $) in Services in 2000 to that in 2002?
Offer a terse response. 0.58. What is the ratio of the Expenses (in $) in Miscellaneous expenses in 2000 to that in 2003?
Your answer should be compact. 1.2. What is the ratio of the Expenses (in $) of Labor Taxes in 2000 to that in 2003?
Offer a very short reply. 1.09. What is the ratio of the Expenses (in $) in Grants and Revenue in 2000 to that in 2003?
Your answer should be compact. 0.36. What is the ratio of the Expenses (in $) of Services in 2000 to that in 2003?
Make the answer very short. 0.57. What is the ratio of the Expenses (in $) of Labor Taxes in 2000 to that in 2004?
Your answer should be compact. 1. What is the ratio of the Expenses (in $) of Grants and Revenue in 2000 to that in 2004?
Offer a very short reply. 0.32. What is the ratio of the Expenses (in $) of Services in 2000 to that in 2004?
Give a very brief answer. 0.54. What is the ratio of the Expenses (in $) of Miscellaneous expenses in 2001 to that in 2002?
Offer a very short reply. 0.98. What is the ratio of the Expenses (in $) of Labor Taxes in 2001 to that in 2002?
Your answer should be very brief. 0.95. What is the ratio of the Expenses (in $) of Grants and Revenue in 2001 to that in 2002?
Your answer should be very brief. 0.89. What is the ratio of the Expenses (in $) in Services in 2001 to that in 2002?
Offer a terse response. 0.88. What is the ratio of the Expenses (in $) of Miscellaneous expenses in 2001 to that in 2003?
Your answer should be very brief. 0.79. What is the ratio of the Expenses (in $) of Labor Taxes in 2001 to that in 2003?
Your answer should be very brief. 0.92. What is the ratio of the Expenses (in $) in Grants and Revenue in 2001 to that in 2003?
Your answer should be very brief. 0.76. What is the ratio of the Expenses (in $) in Services in 2001 to that in 2003?
Make the answer very short. 0.87. What is the ratio of the Expenses (in $) in Miscellaneous expenses in 2001 to that in 2004?
Provide a short and direct response. 0.66. What is the ratio of the Expenses (in $) of Labor Taxes in 2001 to that in 2004?
Provide a short and direct response. 0.85. What is the ratio of the Expenses (in $) of Grants and Revenue in 2001 to that in 2004?
Your response must be concise. 0.68. What is the ratio of the Expenses (in $) in Services in 2001 to that in 2004?
Ensure brevity in your answer.  0.83. What is the ratio of the Expenses (in $) in Miscellaneous expenses in 2002 to that in 2003?
Your response must be concise. 0.8. What is the ratio of the Expenses (in $) in Labor Taxes in 2002 to that in 2003?
Ensure brevity in your answer.  0.97. What is the ratio of the Expenses (in $) of Grants and Revenue in 2002 to that in 2003?
Make the answer very short. 0.85. What is the ratio of the Expenses (in $) in Miscellaneous expenses in 2002 to that in 2004?
Provide a short and direct response. 0.67. What is the ratio of the Expenses (in $) of Labor Taxes in 2002 to that in 2004?
Ensure brevity in your answer.  0.9. What is the ratio of the Expenses (in $) in Grants and Revenue in 2002 to that in 2004?
Give a very brief answer. 0.76. What is the ratio of the Expenses (in $) in Services in 2002 to that in 2004?
Provide a succinct answer. 0.94. What is the ratio of the Expenses (in $) of Miscellaneous expenses in 2003 to that in 2004?
Ensure brevity in your answer.  0.83. What is the ratio of the Expenses (in $) of Labor Taxes in 2003 to that in 2004?
Provide a short and direct response. 0.92. What is the ratio of the Expenses (in $) of Grants and Revenue in 2003 to that in 2004?
Keep it short and to the point. 0.9. What is the ratio of the Expenses (in $) of Services in 2003 to that in 2004?
Your answer should be very brief. 0.95. What is the difference between the highest and the second highest Expenses (in $) in Miscellaneous expenses?
Your answer should be compact. 0. What is the difference between the highest and the second highest Expenses (in $) of Labor Taxes?
Ensure brevity in your answer.  5.30e+06. What is the difference between the highest and the second highest Expenses (in $) in Grants and Revenue?
Keep it short and to the point. 3.15e+08. What is the difference between the highest and the second highest Expenses (in $) of Services?
Make the answer very short. 8.17e+07. What is the difference between the highest and the lowest Expenses (in $) in Miscellaneous expenses?
Keep it short and to the point. 4.99e+07. What is the difference between the highest and the lowest Expenses (in $) of Labor Taxes?
Keep it short and to the point. 2.16e+07. What is the difference between the highest and the lowest Expenses (in $) in Grants and Revenue?
Keep it short and to the point. 2.12e+09. What is the difference between the highest and the lowest Expenses (in $) of Services?
Keep it short and to the point. 7.24e+08. 